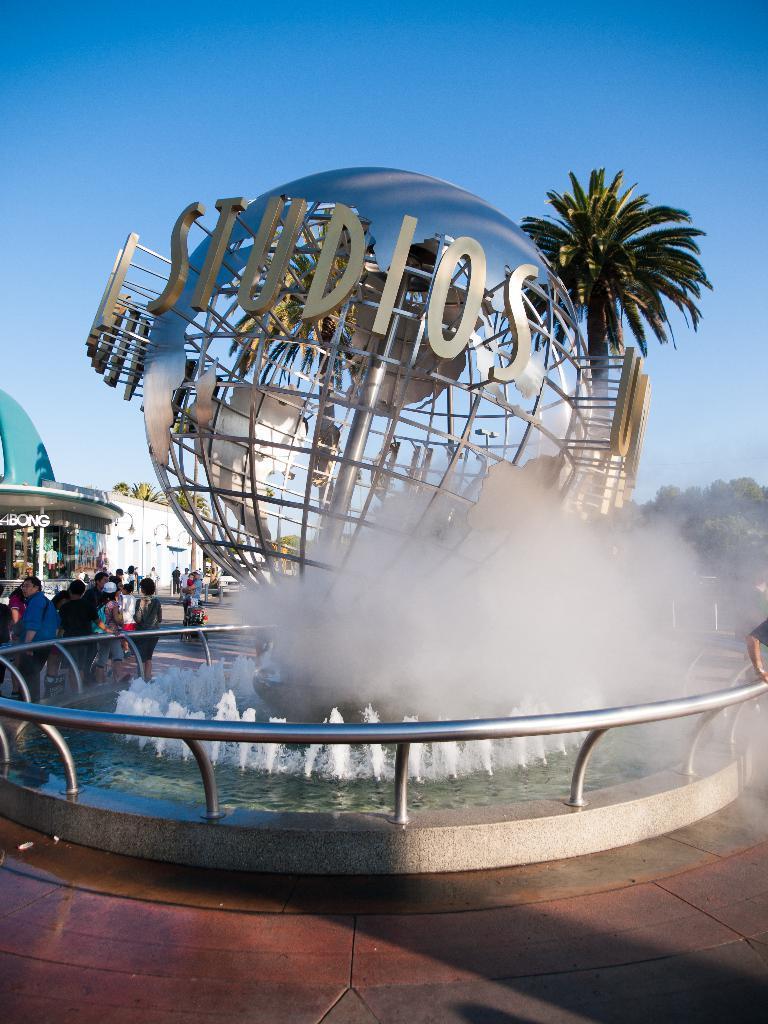In one or two sentences, can you explain what this image depicts? There is a water fountain. Here we can see some persons and there are trees. There is a building. In the background there is sky. 